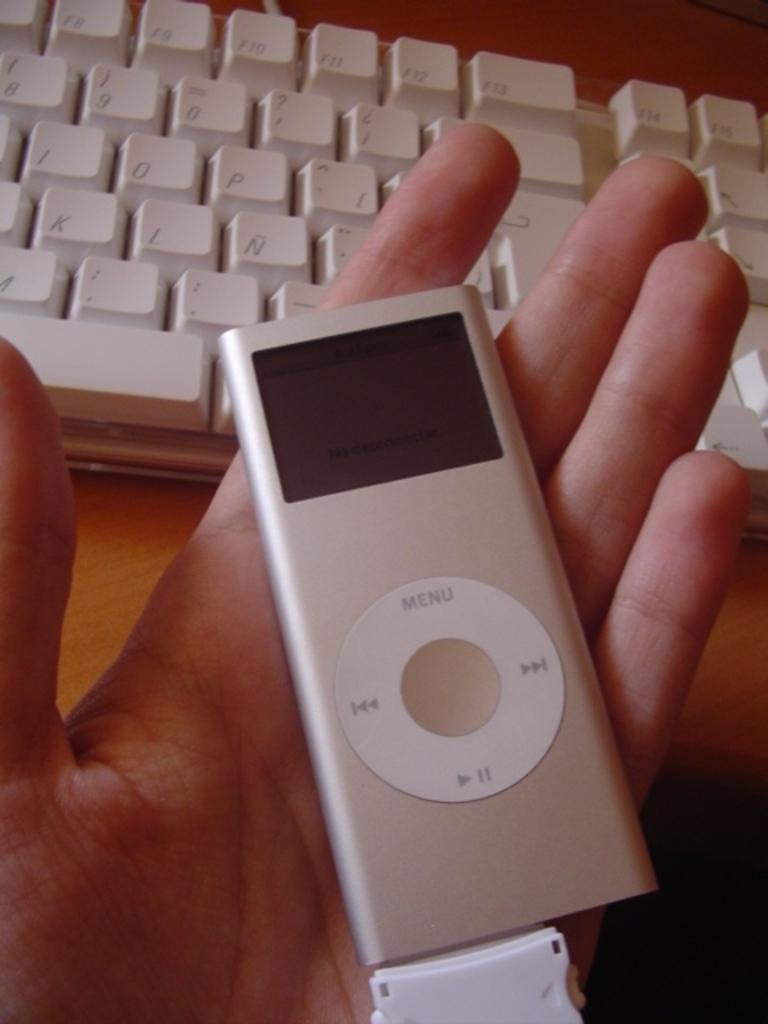Could you give a brief overview of what you see in this image? In this image I can see a person's hand holding a device. At the top there is a keyboard placed on a wooden surface. 